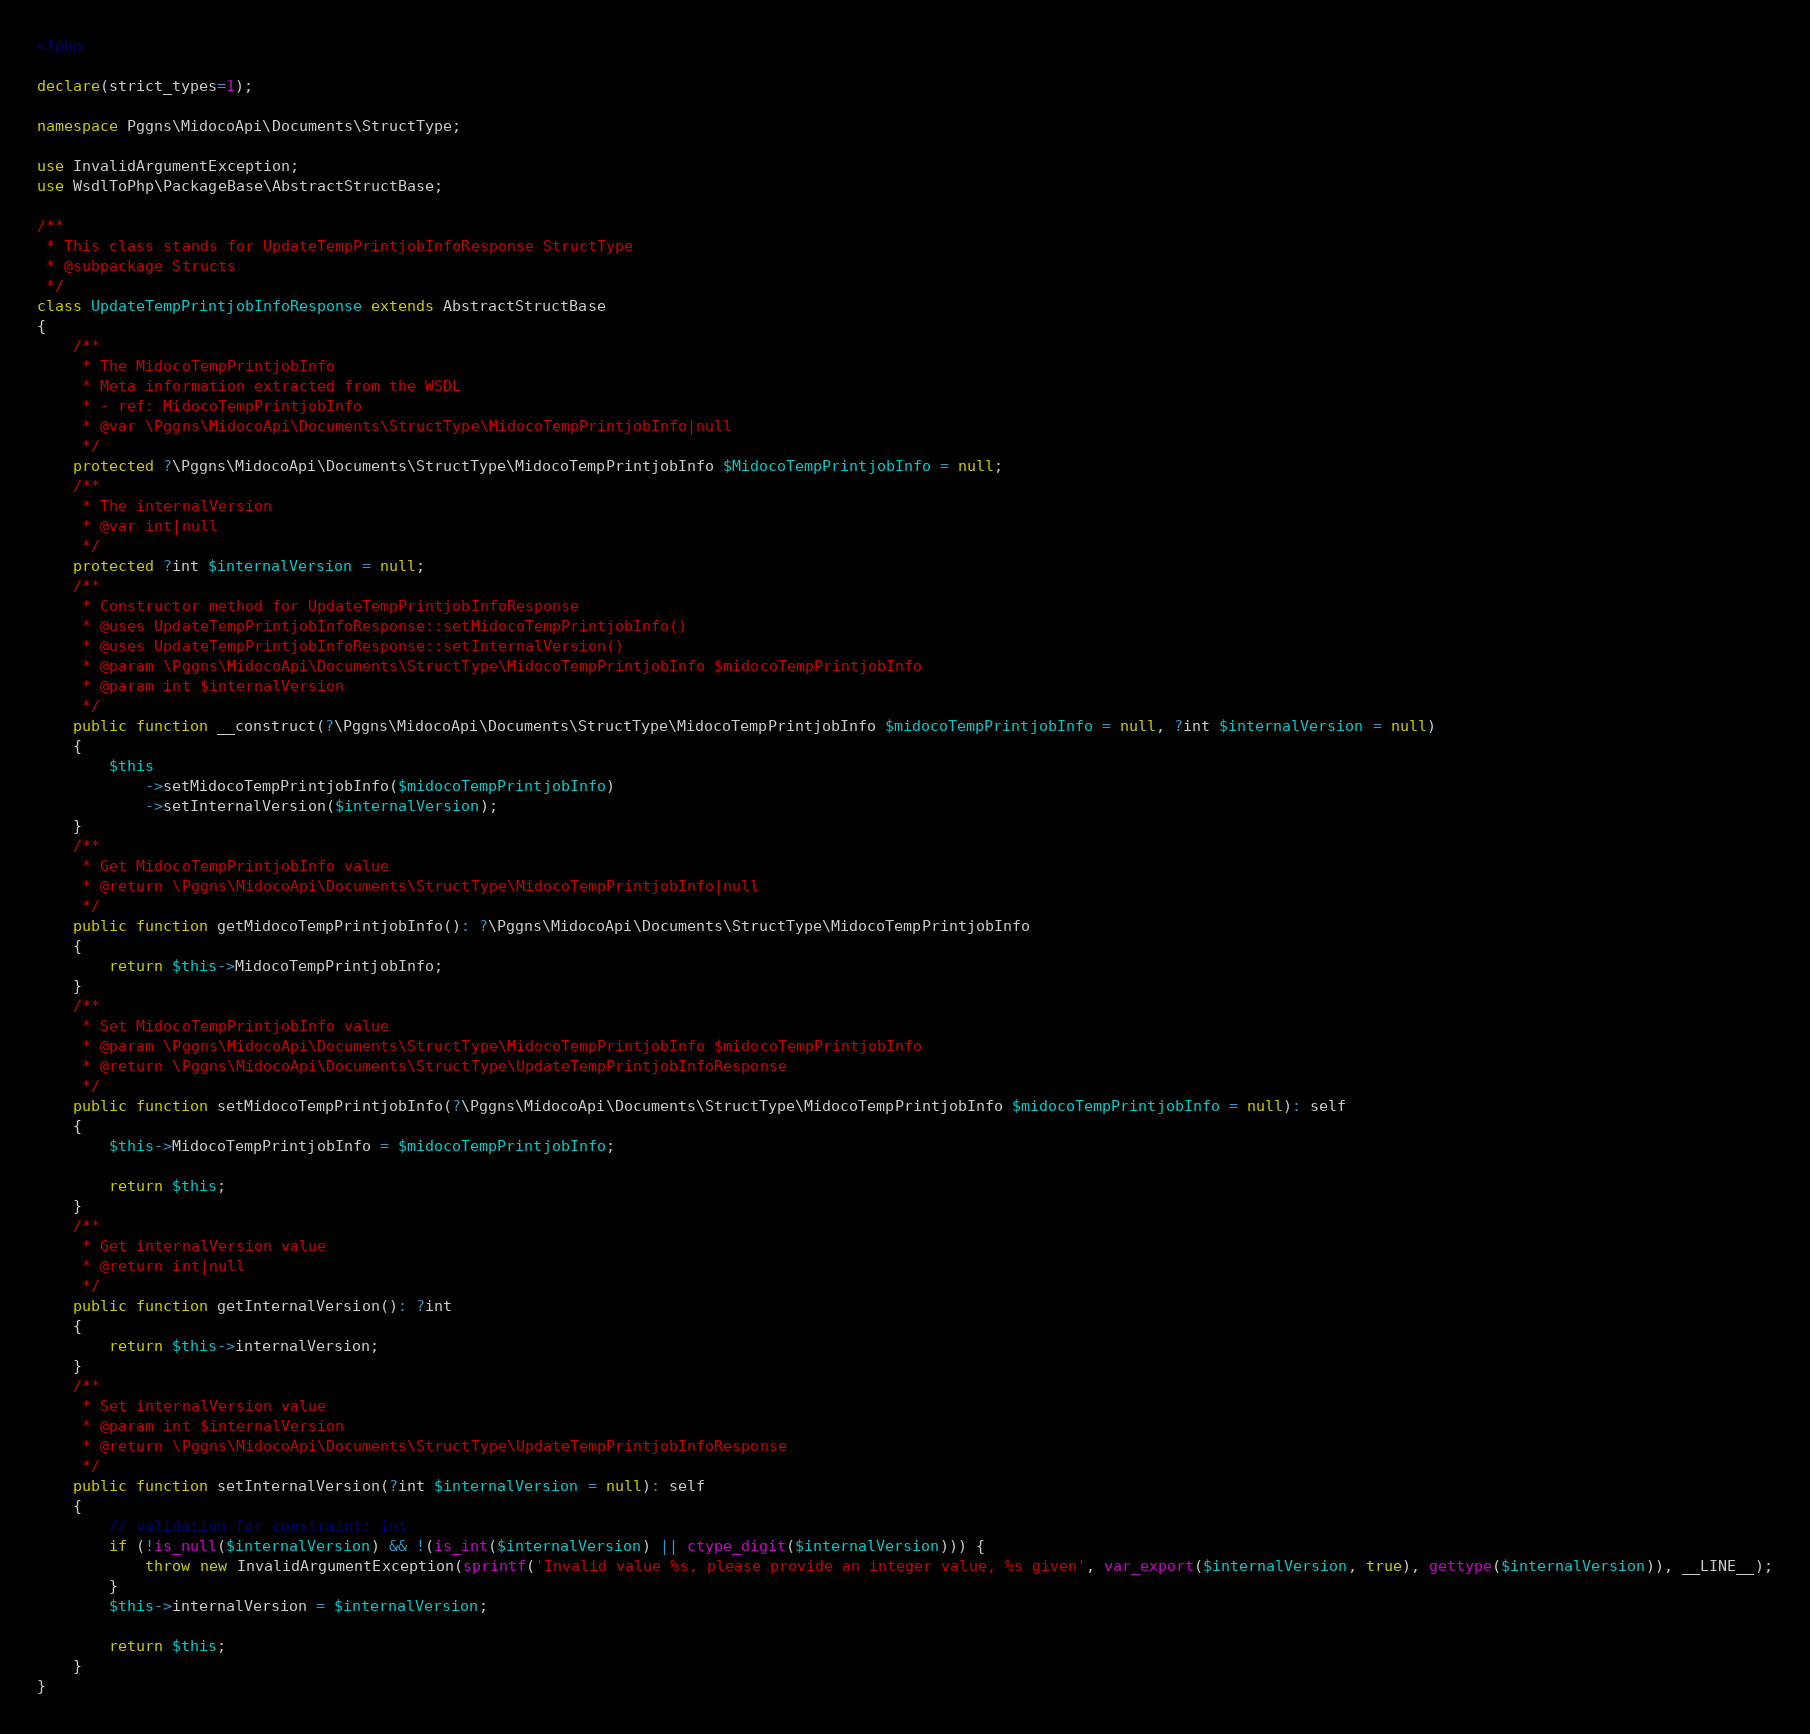Convert code to text. <code><loc_0><loc_0><loc_500><loc_500><_PHP_><?php

declare(strict_types=1);

namespace Pggns\MidocoApi\Documents\StructType;

use InvalidArgumentException;
use WsdlToPhp\PackageBase\AbstractStructBase;

/**
 * This class stands for UpdateTempPrintjobInfoResponse StructType
 * @subpackage Structs
 */
class UpdateTempPrintjobInfoResponse extends AbstractStructBase
{
    /**
     * The MidocoTempPrintjobInfo
     * Meta information extracted from the WSDL
     * - ref: MidocoTempPrintjobInfo
     * @var \Pggns\MidocoApi\Documents\StructType\MidocoTempPrintjobInfo|null
     */
    protected ?\Pggns\MidocoApi\Documents\StructType\MidocoTempPrintjobInfo $MidocoTempPrintjobInfo = null;
    /**
     * The internalVersion
     * @var int|null
     */
    protected ?int $internalVersion = null;
    /**
     * Constructor method for UpdateTempPrintjobInfoResponse
     * @uses UpdateTempPrintjobInfoResponse::setMidocoTempPrintjobInfo()
     * @uses UpdateTempPrintjobInfoResponse::setInternalVersion()
     * @param \Pggns\MidocoApi\Documents\StructType\MidocoTempPrintjobInfo $midocoTempPrintjobInfo
     * @param int $internalVersion
     */
    public function __construct(?\Pggns\MidocoApi\Documents\StructType\MidocoTempPrintjobInfo $midocoTempPrintjobInfo = null, ?int $internalVersion = null)
    {
        $this
            ->setMidocoTempPrintjobInfo($midocoTempPrintjobInfo)
            ->setInternalVersion($internalVersion);
    }
    /**
     * Get MidocoTempPrintjobInfo value
     * @return \Pggns\MidocoApi\Documents\StructType\MidocoTempPrintjobInfo|null
     */
    public function getMidocoTempPrintjobInfo(): ?\Pggns\MidocoApi\Documents\StructType\MidocoTempPrintjobInfo
    {
        return $this->MidocoTempPrintjobInfo;
    }
    /**
     * Set MidocoTempPrintjobInfo value
     * @param \Pggns\MidocoApi\Documents\StructType\MidocoTempPrintjobInfo $midocoTempPrintjobInfo
     * @return \Pggns\MidocoApi\Documents\StructType\UpdateTempPrintjobInfoResponse
     */
    public function setMidocoTempPrintjobInfo(?\Pggns\MidocoApi\Documents\StructType\MidocoTempPrintjobInfo $midocoTempPrintjobInfo = null): self
    {
        $this->MidocoTempPrintjobInfo = $midocoTempPrintjobInfo;
        
        return $this;
    }
    /**
     * Get internalVersion value
     * @return int|null
     */
    public function getInternalVersion(): ?int
    {
        return $this->internalVersion;
    }
    /**
     * Set internalVersion value
     * @param int $internalVersion
     * @return \Pggns\MidocoApi\Documents\StructType\UpdateTempPrintjobInfoResponse
     */
    public function setInternalVersion(?int $internalVersion = null): self
    {
        // validation for constraint: int
        if (!is_null($internalVersion) && !(is_int($internalVersion) || ctype_digit($internalVersion))) {
            throw new InvalidArgumentException(sprintf('Invalid value %s, please provide an integer value, %s given', var_export($internalVersion, true), gettype($internalVersion)), __LINE__);
        }
        $this->internalVersion = $internalVersion;
        
        return $this;
    }
}
</code> 